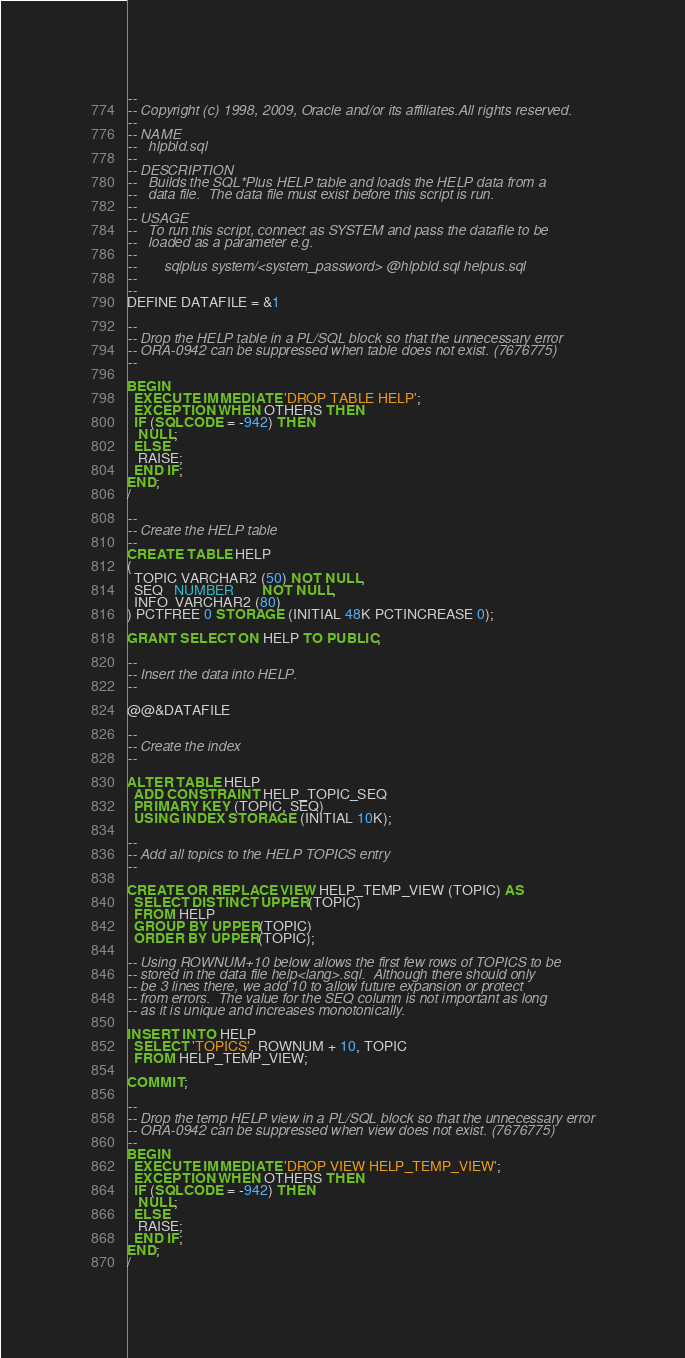Convert code to text. <code><loc_0><loc_0><loc_500><loc_500><_SQL_>--
-- Copyright (c) 1998, 2009, Oracle and/or its affiliates.All rights reserved. 
--
-- NAME
--   hlpbld.sql
--
-- DESCRIPTION
--   Builds the SQL*Plus HELP table and loads the HELP data from a
--   data file.  The data file must exist before this script is run.
--
-- USAGE
--   To run this script, connect as SYSTEM and pass the datafile to be
--   loaded as a parameter e.g.
--
--       sqlplus system/<system_password> @hlpbld.sql helpus.sql
--
--
DEFINE DATAFILE = &1

--
-- Drop the HELP table in a PL/SQL block so that the unnecessary error 
-- ORA-0942 can be suppressed when table does not exist. (7676775)
-- 

BEGIN
  EXECUTE IMMEDIATE 'DROP TABLE HELP';
  EXCEPTION WHEN OTHERS THEN
  IF (SQLCODE = -942) THEN
   NULL;
  ELSE
   RAISE;
  END IF;
END;
/

--
-- Create the HELP table
--
CREATE TABLE HELP
(
  TOPIC VARCHAR2 (50) NOT NULL,
  SEQ   NUMBER        NOT NULL,
  INFO  VARCHAR2 (80)
) PCTFREE 0 STORAGE (INITIAL 48K PCTINCREASE 0);

GRANT SELECT ON HELP TO PUBLIC;

--
-- Insert the data into HELP.
--

@@&DATAFILE

--
-- Create the index
--

ALTER TABLE HELP
  ADD CONSTRAINT HELP_TOPIC_SEQ
  PRIMARY KEY (TOPIC, SEQ)
  USING INDEX STORAGE (INITIAL 10K);

--
-- Add all topics to the HELP TOPICS entry
--

CREATE OR REPLACE VIEW HELP_TEMP_VIEW (TOPIC) AS
  SELECT DISTINCT UPPER(TOPIC)
  FROM HELP
  GROUP BY UPPER(TOPIC)
  ORDER BY UPPER(TOPIC);

-- Using ROWNUM+10 below allows the first few rows of TOPICS to be
-- stored in the data file help<lang>.sql.  Although there should only
-- be 3 lines there, we add 10 to allow future expansion or protect
-- from errors.  The value for the SEQ column is not important as long
-- as it is unique and increases monotonically.

INSERT INTO HELP
  SELECT 'TOPICS', ROWNUM + 10, TOPIC
  FROM HELP_TEMP_VIEW;

COMMIT;

--
-- Drop the temp HELP view in a PL/SQL block so that the unnecessary error 
-- ORA-0942 can be suppressed when view does not exist. (7676775)
-- 
BEGIN
  EXECUTE IMMEDIATE 'DROP VIEW HELP_TEMP_VIEW';
  EXCEPTION WHEN OTHERS THEN
  IF (SQLCODE = -942) THEN
   NULL;
  ELSE
   RAISE;
  END IF;
END;
/
</code> 